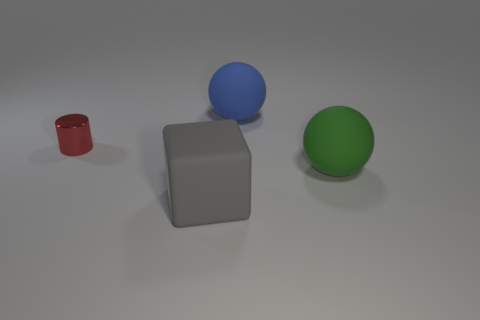Is the number of rubber blocks that are behind the green rubber object greater than the number of green rubber balls?
Ensure brevity in your answer.  No. How many other objects are the same color as the big cube?
Give a very brief answer. 0. There is a gray thing that is the same size as the green matte sphere; what is its shape?
Make the answer very short. Cube. What number of large balls are to the left of the big sphere right of the thing that is behind the red metal cylinder?
Ensure brevity in your answer.  1. How many matte things are either cylinders or large yellow blocks?
Make the answer very short. 0. What color is the thing that is behind the block and in front of the tiny metallic thing?
Your response must be concise. Green. Is the size of the thing that is behind the red cylinder the same as the red shiny cylinder?
Provide a succinct answer. No. What number of things are either big matte things behind the small metal object or tiny metallic cylinders?
Make the answer very short. 2. Are there any green objects that have the same size as the metallic cylinder?
Your answer should be very brief. No. There is a gray thing that is the same size as the green matte ball; what is it made of?
Ensure brevity in your answer.  Rubber. 